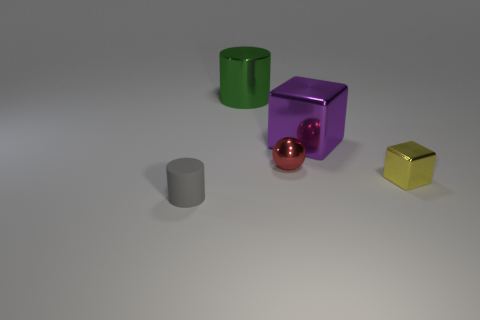Add 4 red cylinders. How many objects exist? 9 Subtract all blocks. How many objects are left? 3 Subtract 0 brown spheres. How many objects are left? 5 Subtract all tiny gray blocks. Subtract all purple blocks. How many objects are left? 4 Add 4 purple objects. How many purple objects are left? 5 Add 4 small yellow objects. How many small yellow objects exist? 5 